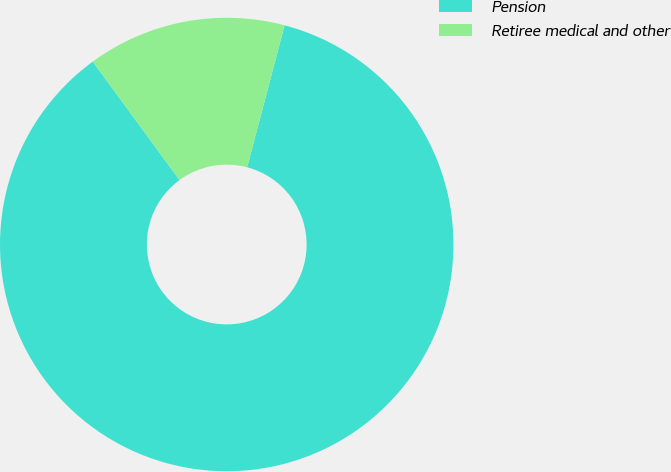<chart> <loc_0><loc_0><loc_500><loc_500><pie_chart><fcel>Pension<fcel>Retiree medical and other<nl><fcel>85.83%<fcel>14.17%<nl></chart> 